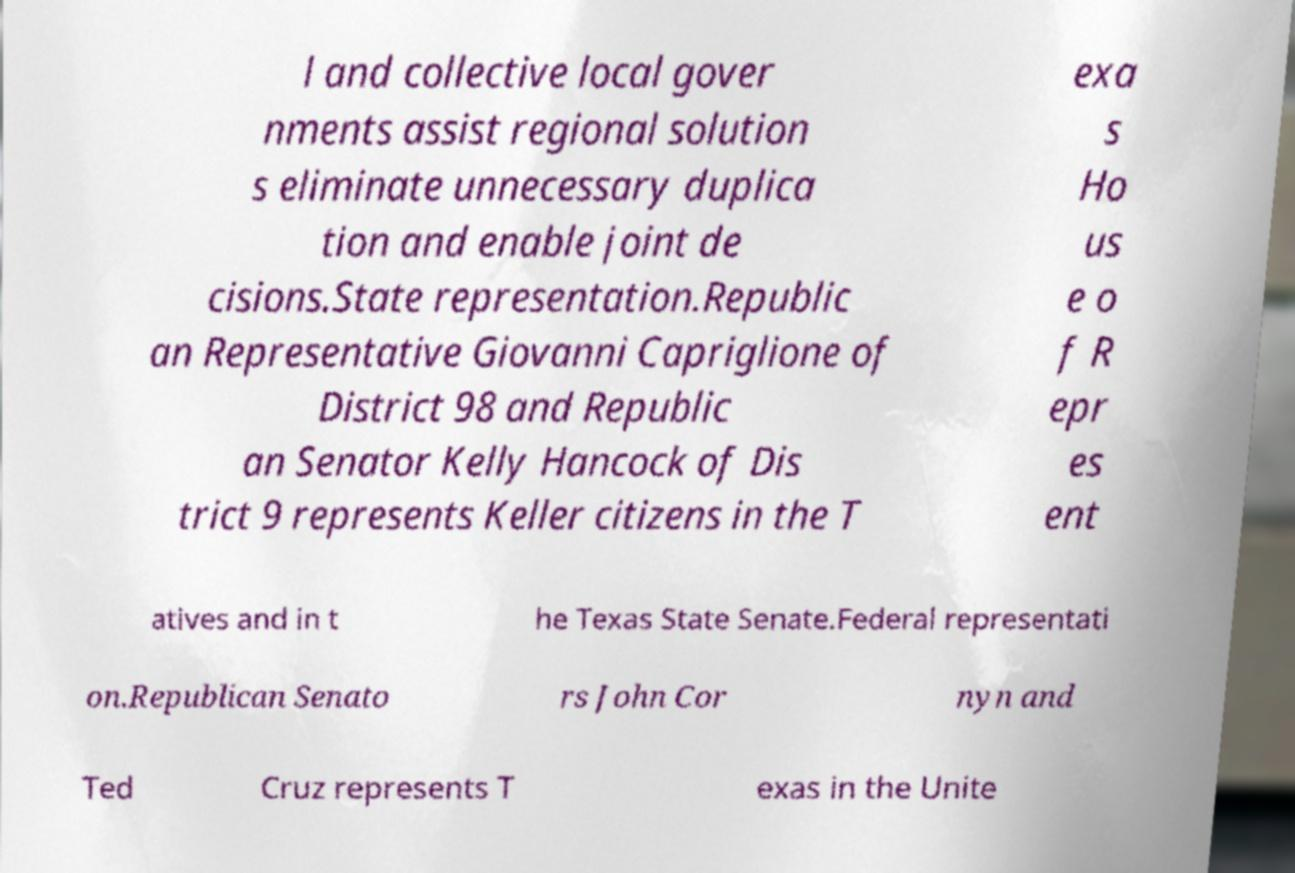Can you read and provide the text displayed in the image?This photo seems to have some interesting text. Can you extract and type it out for me? l and collective local gover nments assist regional solution s eliminate unnecessary duplica tion and enable joint de cisions.State representation.Republic an Representative Giovanni Capriglione of District 98 and Republic an Senator Kelly Hancock of Dis trict 9 represents Keller citizens in the T exa s Ho us e o f R epr es ent atives and in t he Texas State Senate.Federal representati on.Republican Senato rs John Cor nyn and Ted Cruz represents T exas in the Unite 